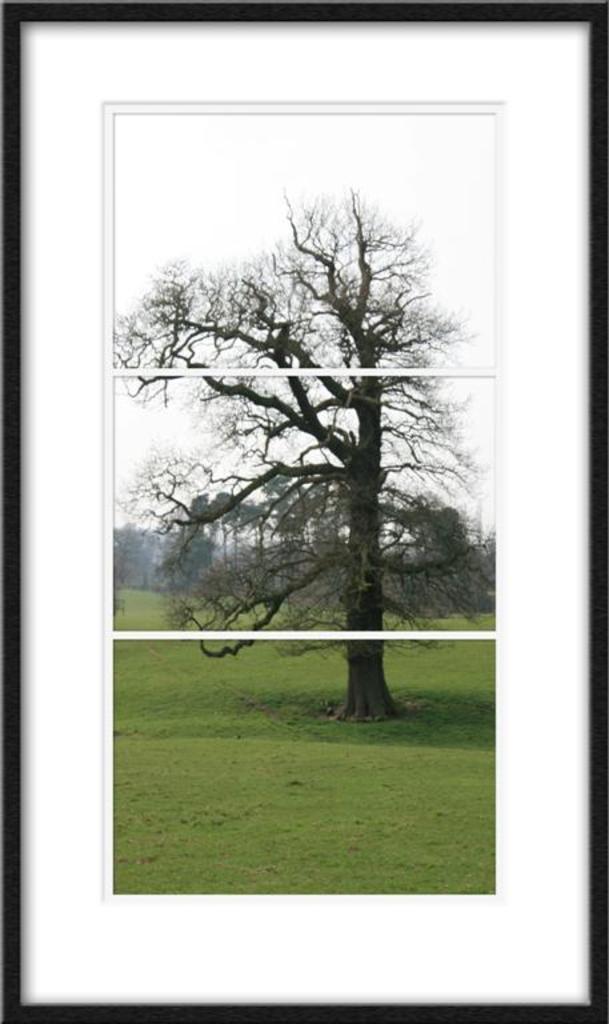In one or two sentences, can you explain what this image depicts? In the center of the image we can see a photo frame. On the photo frame, we can see the sky, trees and grass. 